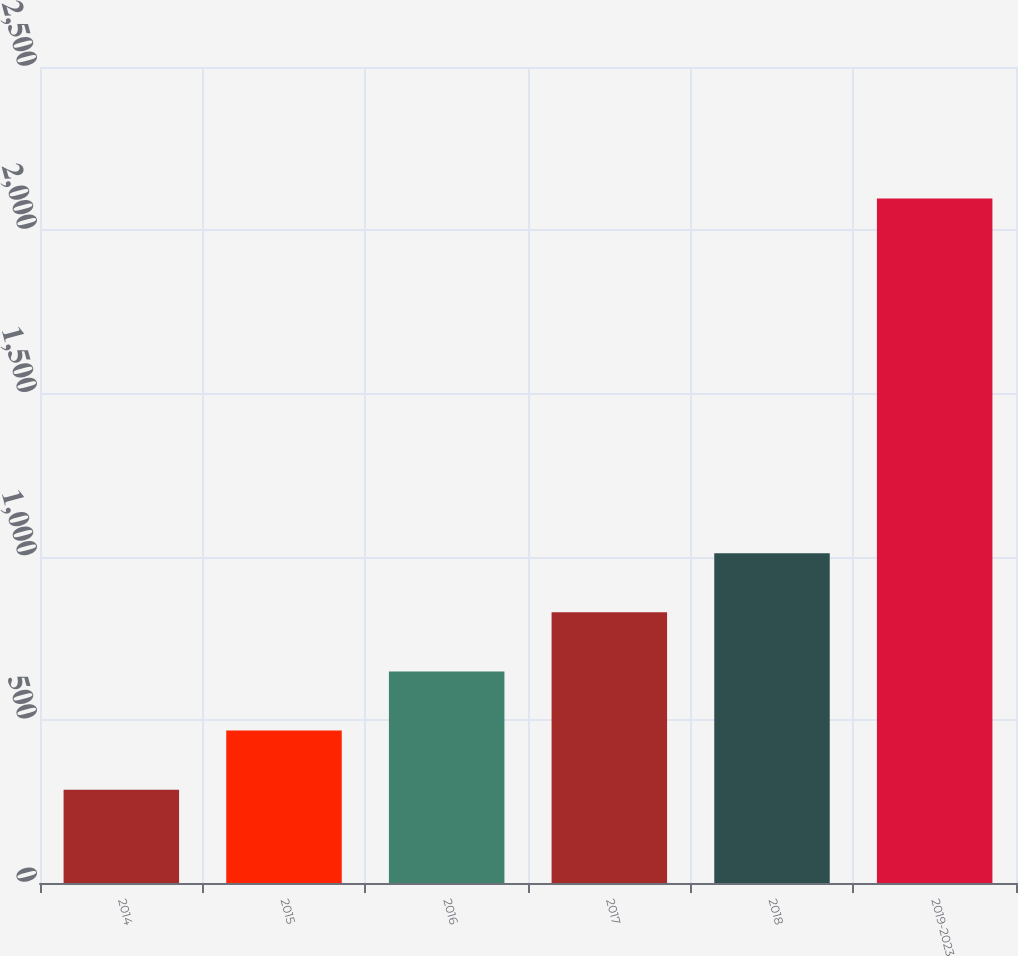Convert chart to OTSL. <chart><loc_0><loc_0><loc_500><loc_500><bar_chart><fcel>2014<fcel>2015<fcel>2016<fcel>2017<fcel>2018<fcel>2019-2023<nl><fcel>286<fcel>467.1<fcel>648.2<fcel>829.3<fcel>1010.4<fcel>2097<nl></chart> 